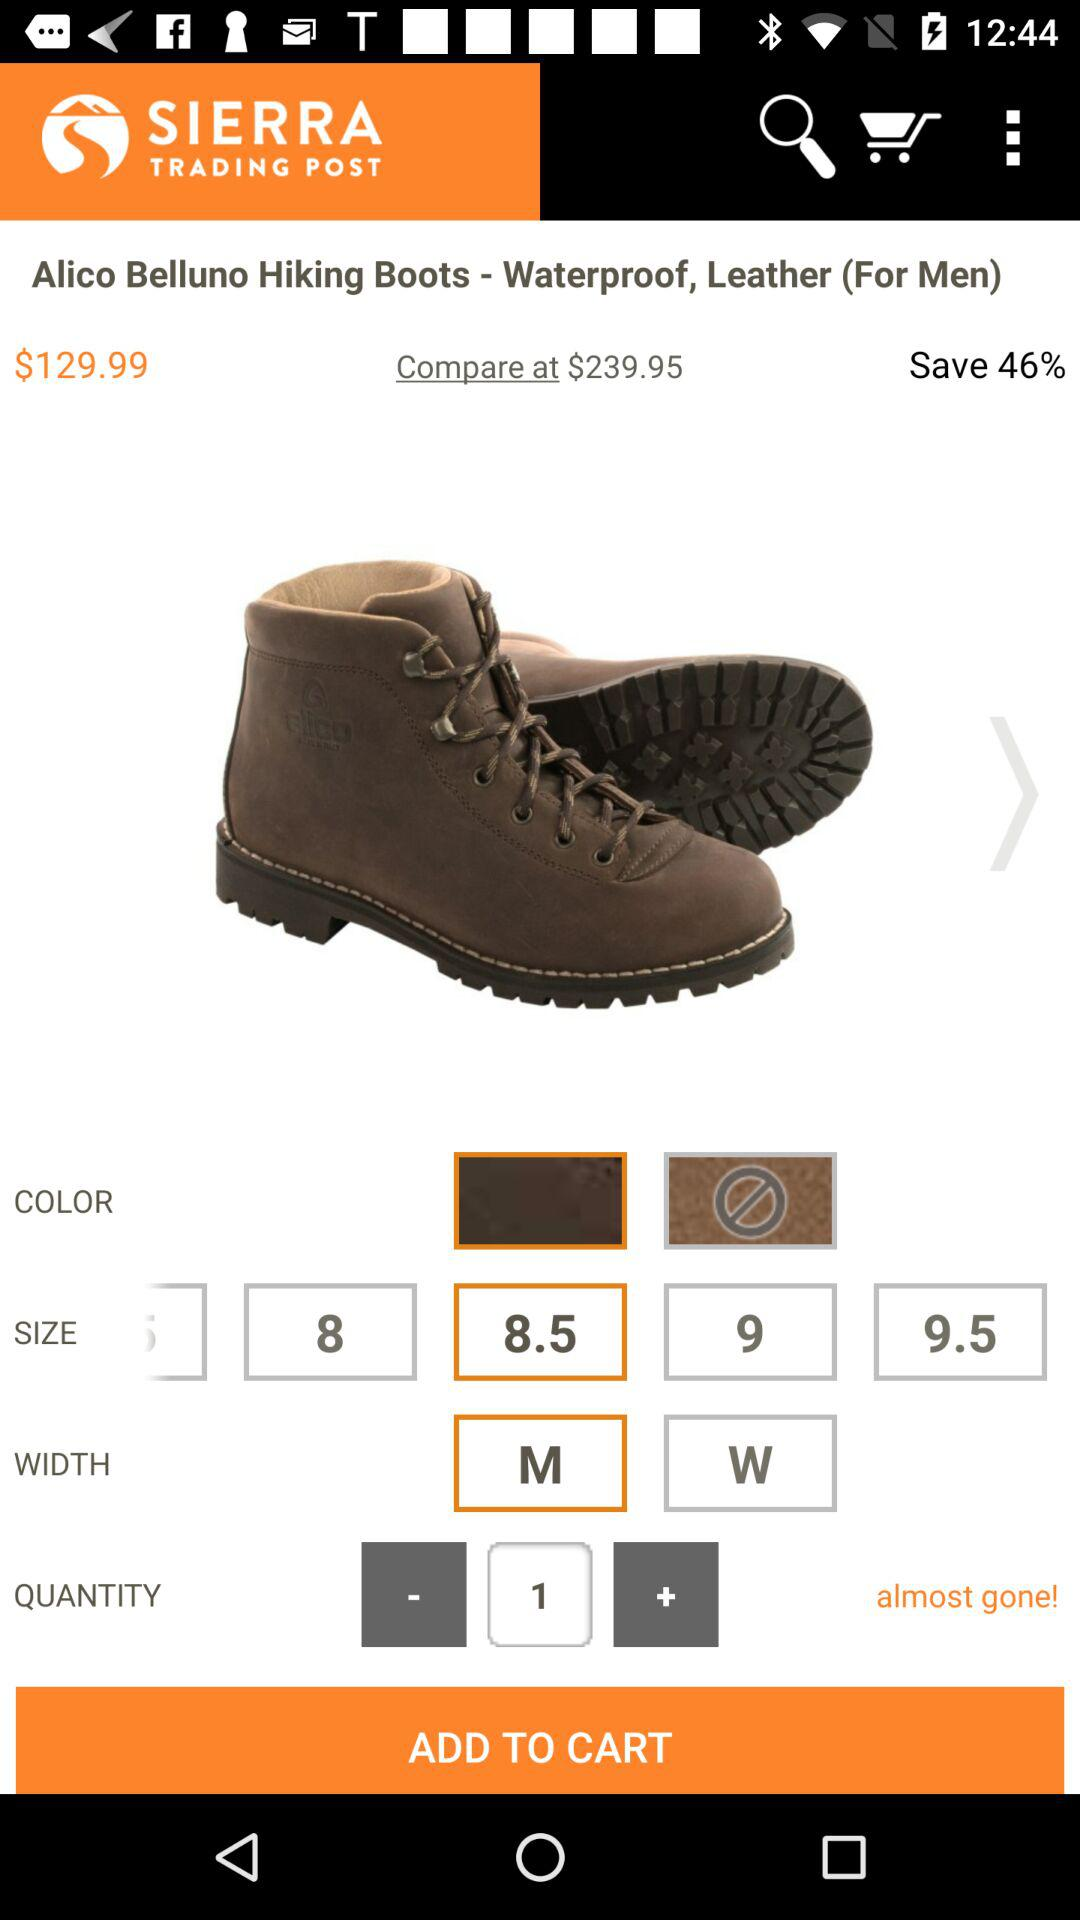How many different widths are available for this product?
Answer the question using a single word or phrase. 2 